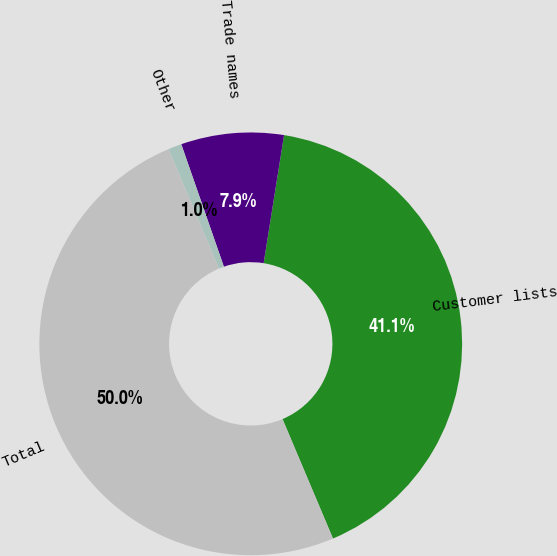<chart> <loc_0><loc_0><loc_500><loc_500><pie_chart><fcel>Customer lists<fcel>Trade names<fcel>Other<fcel>Total<nl><fcel>41.12%<fcel>7.85%<fcel>1.03%<fcel>50.0%<nl></chart> 